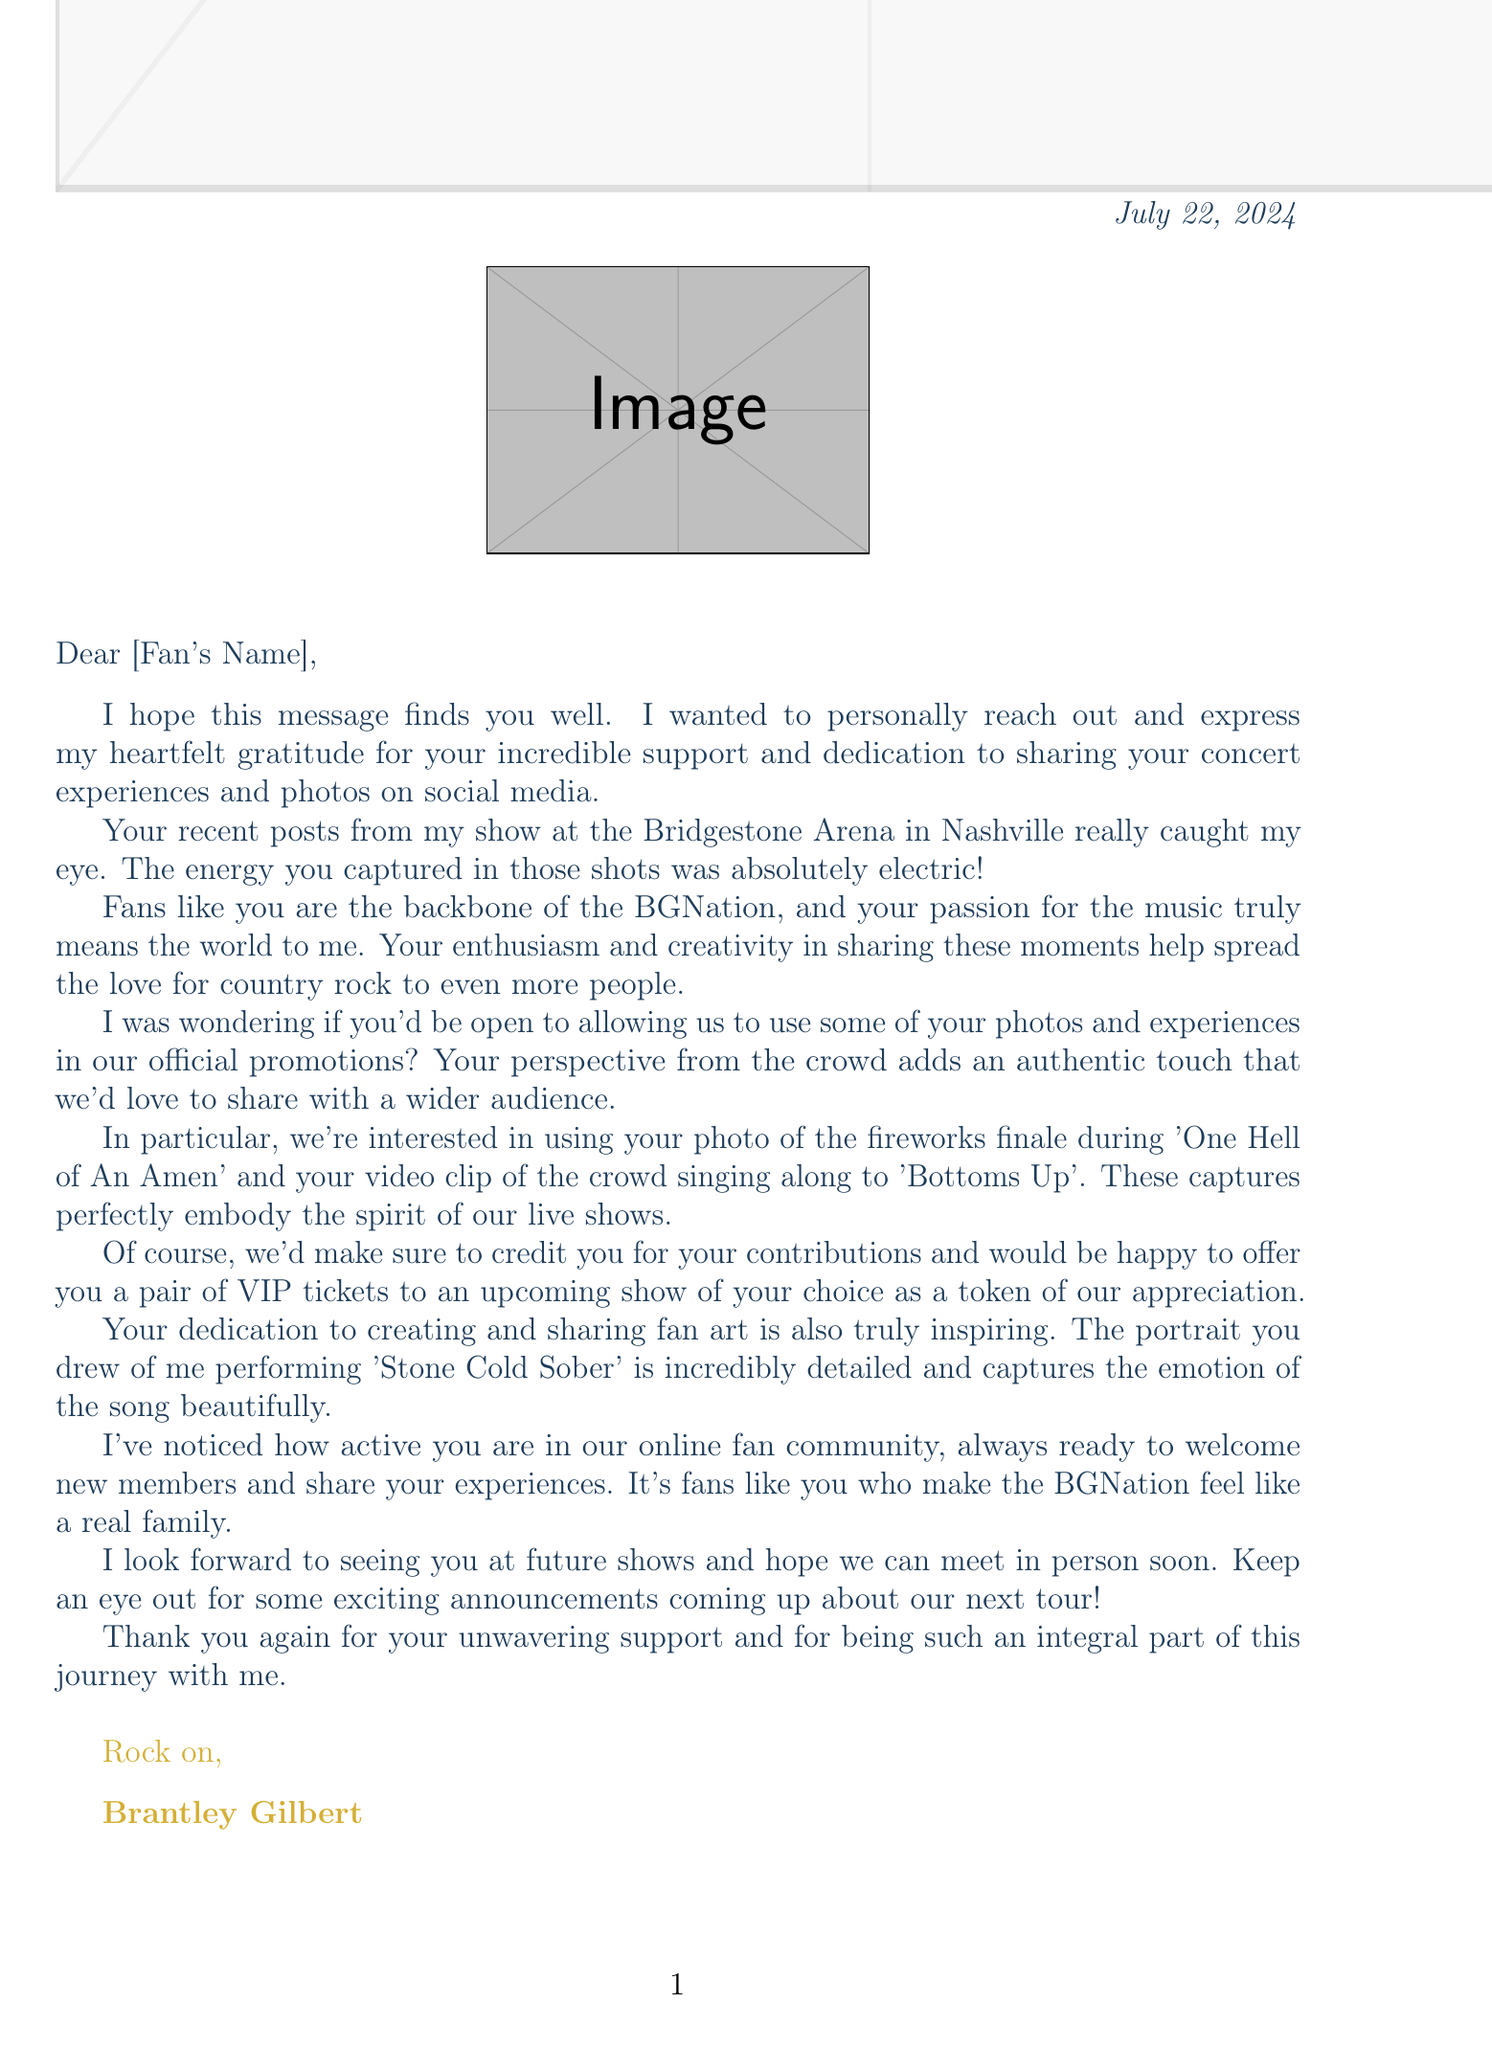What is the recipient's name in the letter? The letter uses the placeholder "[Fan's Name]" to address the recipient directly.
Answer: [Fan's Name] Which concert is mentioned in the letter? The letter specifically references the concert at the Bridgestone Arena in Nashville.
Answer: Bridgestone Arena What date did the referenced concert take place? The date of the concert mentioned in the letter is clearly stated.
Answer: June 15, 2023 What two songs are requested for promotional use? The letter explicitly requests a photo and a video clip related to two songs for promotions.
Answer: One Hell of An Amen, Bottoms Up What is offered as a token of appreciation? The letter mentions a specific reward for the fan contributing content for promotions.
Answer: a pair of VIP tickets What is the name of Brantley Gilbert's fan community? The letter acknowledges an online group that the fan is part of.
Answer: BGNation What is the primary sentiment expressed in the opening of the letter? The opening expresses gratitude for the fan's dedication and support.
Answer: heartfelt gratitude What type of art is acknowledged in the letter? The letter refers to a specific type of artistic contribution made by the fan.
Answer: fan art What will the fan retain after granting permission for the use of their content? The letter includes a legal note about content ownership.
Answer: ownership of your content 